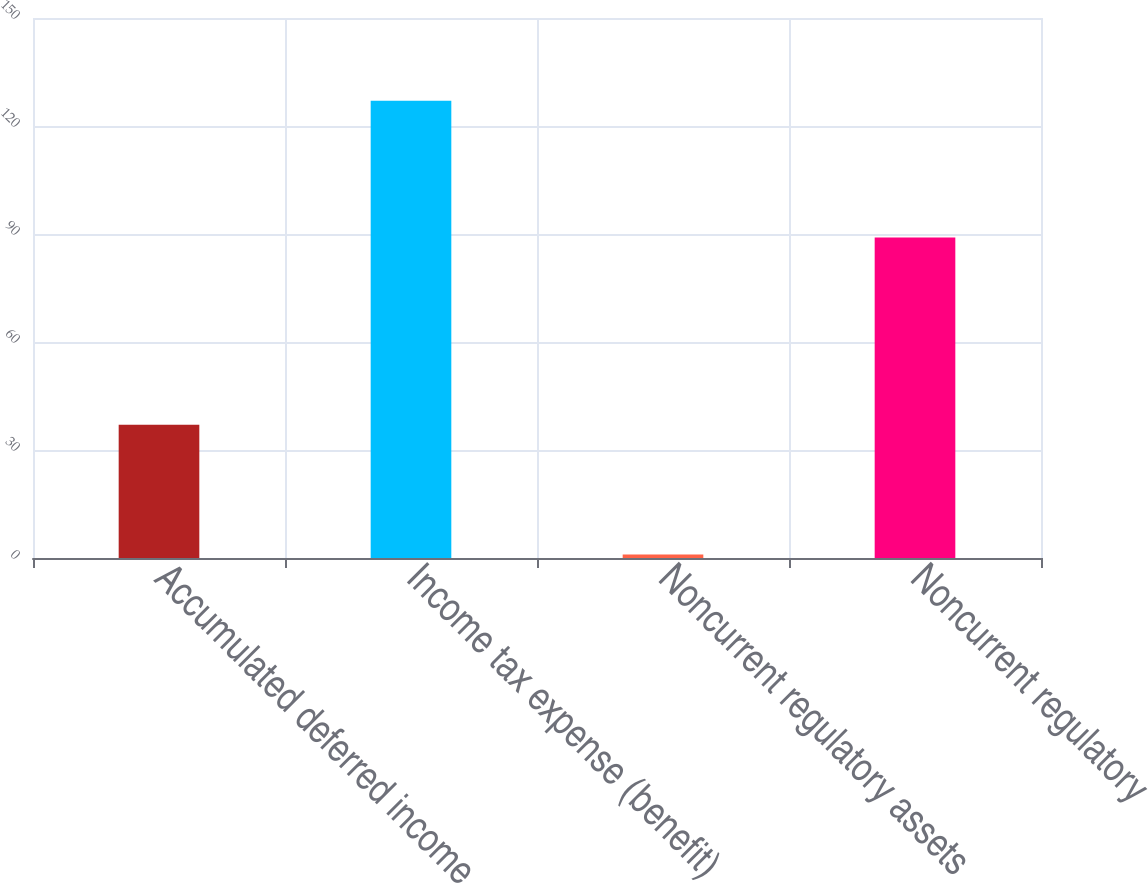Convert chart. <chart><loc_0><loc_0><loc_500><loc_500><bar_chart><fcel>Accumulated deferred income<fcel>Income tax expense (benefit)<fcel>Noncurrent regulatory assets<fcel>Noncurrent regulatory<nl><fcel>37<fcel>127<fcel>1<fcel>89<nl></chart> 